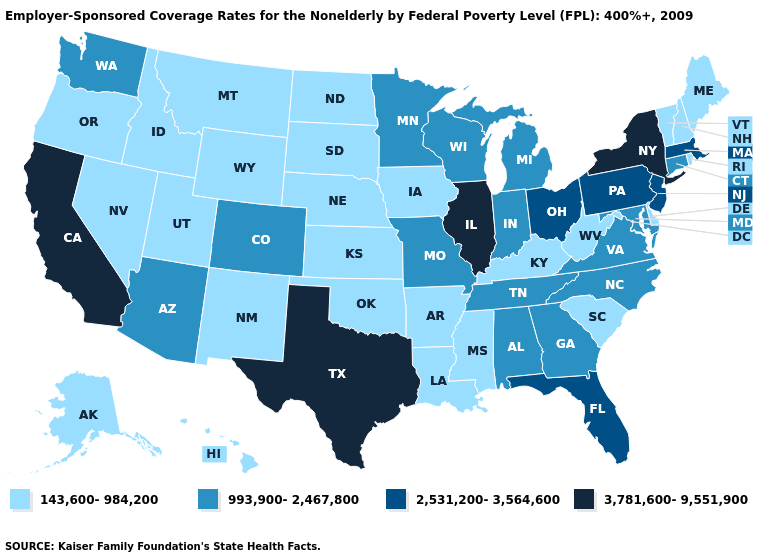How many symbols are there in the legend?
Concise answer only. 4. What is the value of Indiana?
Quick response, please. 993,900-2,467,800. Does Illinois have the highest value in the USA?
Answer briefly. Yes. Does Indiana have the lowest value in the MidWest?
Short answer required. No. Name the states that have a value in the range 143,600-984,200?
Answer briefly. Alaska, Arkansas, Delaware, Hawaii, Idaho, Iowa, Kansas, Kentucky, Louisiana, Maine, Mississippi, Montana, Nebraska, Nevada, New Hampshire, New Mexico, North Dakota, Oklahoma, Oregon, Rhode Island, South Carolina, South Dakota, Utah, Vermont, West Virginia, Wyoming. Name the states that have a value in the range 143,600-984,200?
Give a very brief answer. Alaska, Arkansas, Delaware, Hawaii, Idaho, Iowa, Kansas, Kentucky, Louisiana, Maine, Mississippi, Montana, Nebraska, Nevada, New Hampshire, New Mexico, North Dakota, Oklahoma, Oregon, Rhode Island, South Carolina, South Dakota, Utah, Vermont, West Virginia, Wyoming. What is the value of Florida?
Keep it brief. 2,531,200-3,564,600. How many symbols are there in the legend?
Quick response, please. 4. Does New Hampshire have the lowest value in the USA?
Concise answer only. Yes. Does Indiana have the same value as Kentucky?
Concise answer only. No. Among the states that border Missouri , which have the lowest value?
Keep it brief. Arkansas, Iowa, Kansas, Kentucky, Nebraska, Oklahoma. Which states have the lowest value in the West?
Quick response, please. Alaska, Hawaii, Idaho, Montana, Nevada, New Mexico, Oregon, Utah, Wyoming. Name the states that have a value in the range 993,900-2,467,800?
Be succinct. Alabama, Arizona, Colorado, Connecticut, Georgia, Indiana, Maryland, Michigan, Minnesota, Missouri, North Carolina, Tennessee, Virginia, Washington, Wisconsin. Name the states that have a value in the range 3,781,600-9,551,900?
Answer briefly. California, Illinois, New York, Texas. What is the lowest value in the MidWest?
Concise answer only. 143,600-984,200. 